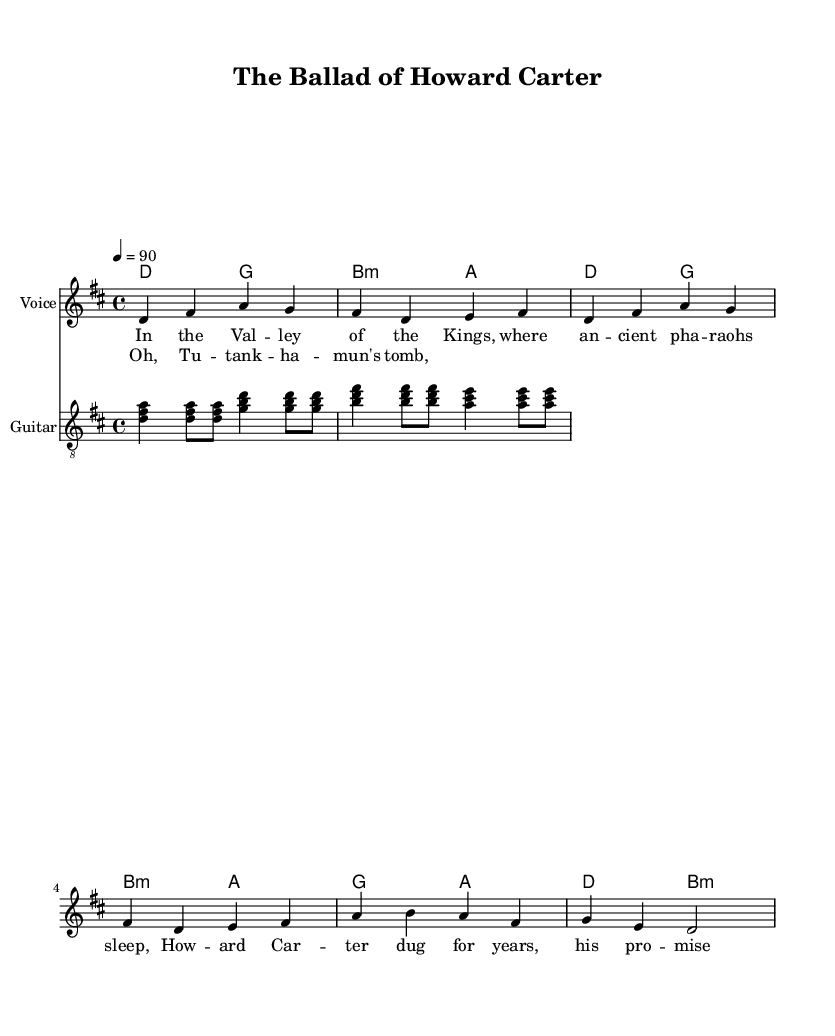What is the key signature of this music? The key signature is D major, indicated by two sharps (F# and C#), which are noted at the beginning of the music.
Answer: D major What is the time signature of this piece? The time signature is 4/4, as seen at the beginning of the music score, which indicates that there are four beats per measure.
Answer: 4/4 What is the tempo marking for this piece? The tempo marking specifies a speed of 90 beats per minute, indicated above the staff with "4 = 90".
Answer: 90 How many measures are in the chorus section? To find the number of measures in the chorus, we count the measures in the chorus lyrics, which consist of two lines with four beats each, totaling two measures.
Answer: 2 What instruments are indicated in the score? The score mentions two instruments: "Voice" for singing, and "Guitar" for accompaniment, stated at the beginning of each staff.
Answer: Voice and Guitar How does the chorus relate to the verses musically? The chorus follows the verses and uses the same rhythmic structure but with different melodic notes, creating a contrast while maintaining cohesion in thematic storytelling.
Answer: Contrast and cohesion 